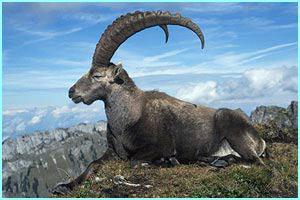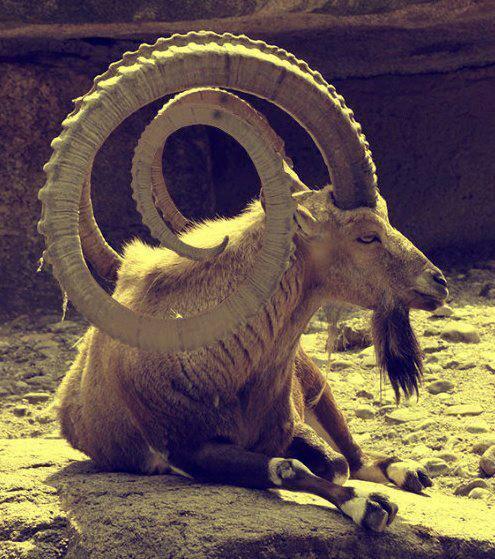The first image is the image on the left, the second image is the image on the right. Considering the images on both sides, is "The left image contains one reclining long-horned animal with its front legs folded under and its head turned to face the camera." valid? Answer yes or no. No. 